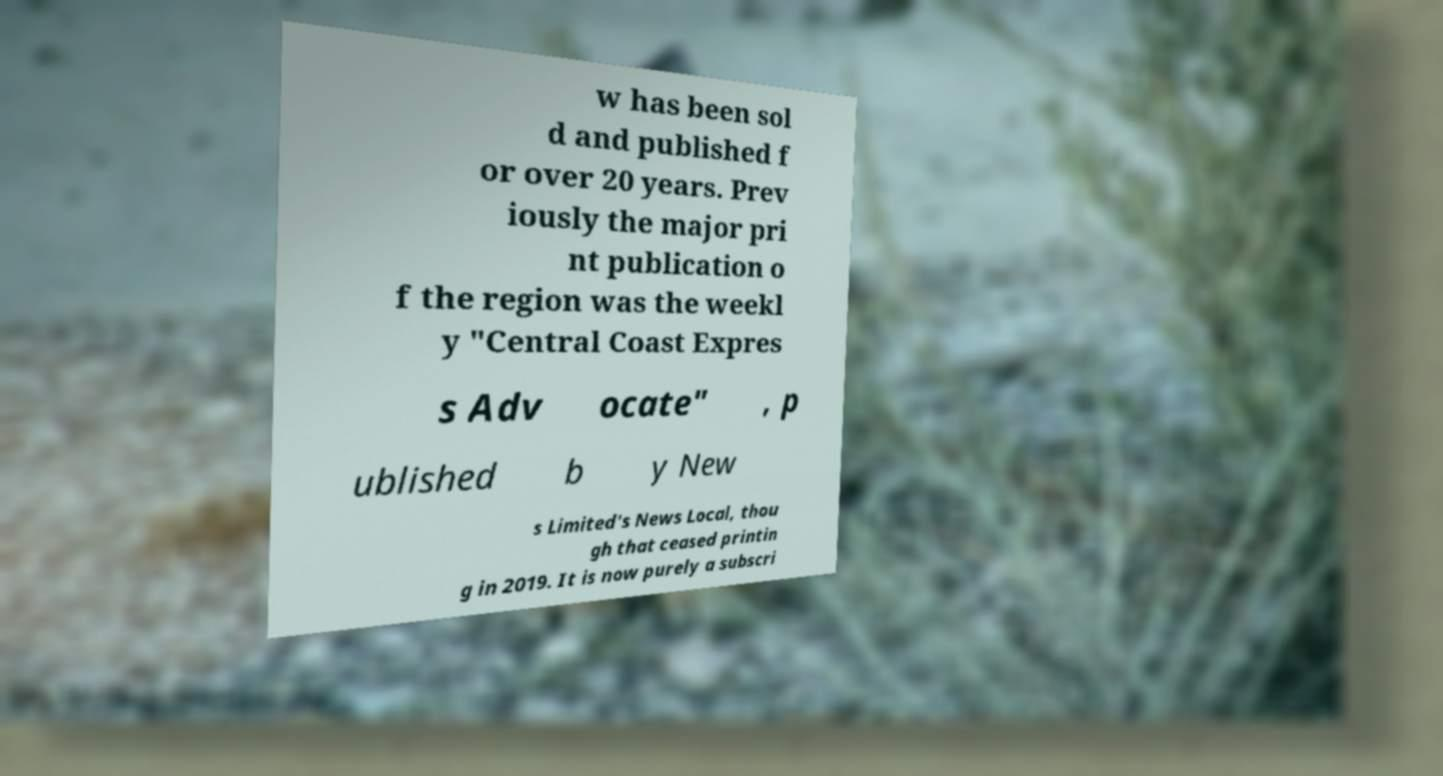Please read and relay the text visible in this image. What does it say? w has been sol d and published f or over 20 years. Prev iously the major pri nt publication o f the region was the weekl y "Central Coast Expres s Adv ocate" , p ublished b y New s Limited's News Local, thou gh that ceased printin g in 2019. It is now purely a subscri 